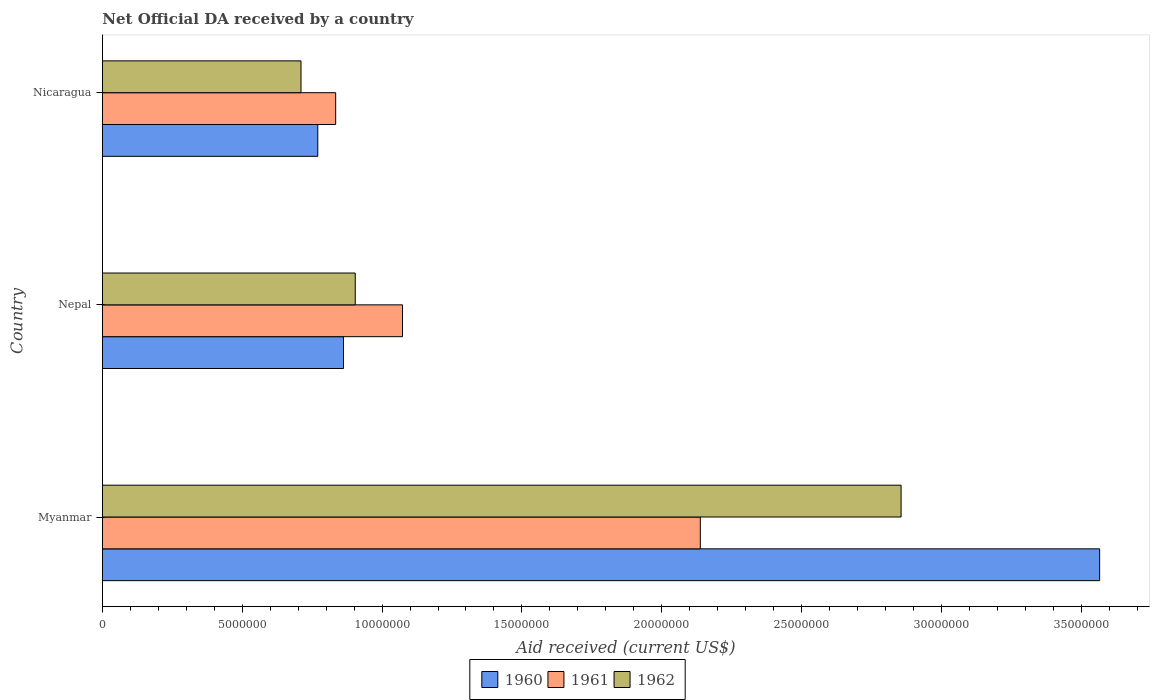Are the number of bars on each tick of the Y-axis equal?
Your answer should be compact. Yes. How many bars are there on the 3rd tick from the top?
Your answer should be compact. 3. How many bars are there on the 3rd tick from the bottom?
Make the answer very short. 3. What is the label of the 3rd group of bars from the top?
Provide a succinct answer. Myanmar. In how many cases, is the number of bars for a given country not equal to the number of legend labels?
Your answer should be very brief. 0. What is the net official development assistance aid received in 1960 in Nepal?
Your response must be concise. 8.62e+06. Across all countries, what is the maximum net official development assistance aid received in 1961?
Keep it short and to the point. 2.14e+07. Across all countries, what is the minimum net official development assistance aid received in 1960?
Make the answer very short. 7.70e+06. In which country was the net official development assistance aid received in 1960 maximum?
Make the answer very short. Myanmar. In which country was the net official development assistance aid received in 1960 minimum?
Keep it short and to the point. Nicaragua. What is the total net official development assistance aid received in 1960 in the graph?
Provide a short and direct response. 5.20e+07. What is the difference between the net official development assistance aid received in 1960 in Nepal and that in Nicaragua?
Keep it short and to the point. 9.20e+05. What is the difference between the net official development assistance aid received in 1960 in Nicaragua and the net official development assistance aid received in 1962 in Nepal?
Provide a succinct answer. -1.34e+06. What is the average net official development assistance aid received in 1962 per country?
Keep it short and to the point. 1.49e+07. What is the difference between the net official development assistance aid received in 1960 and net official development assistance aid received in 1962 in Myanmar?
Your response must be concise. 7.10e+06. What is the ratio of the net official development assistance aid received in 1960 in Myanmar to that in Nicaragua?
Offer a terse response. 4.63. Is the net official development assistance aid received in 1961 in Myanmar less than that in Nicaragua?
Ensure brevity in your answer.  No. Is the difference between the net official development assistance aid received in 1960 in Myanmar and Nepal greater than the difference between the net official development assistance aid received in 1962 in Myanmar and Nepal?
Offer a very short reply. Yes. What is the difference between the highest and the second highest net official development assistance aid received in 1960?
Offer a terse response. 2.70e+07. What is the difference between the highest and the lowest net official development assistance aid received in 1960?
Ensure brevity in your answer.  2.80e+07. In how many countries, is the net official development assistance aid received in 1960 greater than the average net official development assistance aid received in 1960 taken over all countries?
Your answer should be very brief. 1. What does the 3rd bar from the top in Myanmar represents?
Offer a terse response. 1960. What does the 2nd bar from the bottom in Nicaragua represents?
Offer a terse response. 1961. Is it the case that in every country, the sum of the net official development assistance aid received in 1961 and net official development assistance aid received in 1962 is greater than the net official development assistance aid received in 1960?
Keep it short and to the point. Yes. How many bars are there?
Offer a terse response. 9. What is the difference between two consecutive major ticks on the X-axis?
Offer a very short reply. 5.00e+06. Are the values on the major ticks of X-axis written in scientific E-notation?
Provide a short and direct response. No. Does the graph contain any zero values?
Your answer should be very brief. No. How are the legend labels stacked?
Offer a very short reply. Horizontal. What is the title of the graph?
Your answer should be compact. Net Official DA received by a country. What is the label or title of the X-axis?
Your answer should be very brief. Aid received (current US$). What is the label or title of the Y-axis?
Provide a short and direct response. Country. What is the Aid received (current US$) of 1960 in Myanmar?
Your response must be concise. 3.57e+07. What is the Aid received (current US$) of 1961 in Myanmar?
Your answer should be very brief. 2.14e+07. What is the Aid received (current US$) in 1962 in Myanmar?
Ensure brevity in your answer.  2.86e+07. What is the Aid received (current US$) of 1960 in Nepal?
Provide a short and direct response. 8.62e+06. What is the Aid received (current US$) of 1961 in Nepal?
Ensure brevity in your answer.  1.07e+07. What is the Aid received (current US$) of 1962 in Nepal?
Your answer should be compact. 9.04e+06. What is the Aid received (current US$) in 1960 in Nicaragua?
Ensure brevity in your answer.  7.70e+06. What is the Aid received (current US$) in 1961 in Nicaragua?
Keep it short and to the point. 8.34e+06. What is the Aid received (current US$) of 1962 in Nicaragua?
Your answer should be very brief. 7.10e+06. Across all countries, what is the maximum Aid received (current US$) of 1960?
Offer a very short reply. 3.57e+07. Across all countries, what is the maximum Aid received (current US$) in 1961?
Your response must be concise. 2.14e+07. Across all countries, what is the maximum Aid received (current US$) of 1962?
Make the answer very short. 2.86e+07. Across all countries, what is the minimum Aid received (current US$) of 1960?
Your response must be concise. 7.70e+06. Across all countries, what is the minimum Aid received (current US$) in 1961?
Provide a short and direct response. 8.34e+06. Across all countries, what is the minimum Aid received (current US$) in 1962?
Offer a very short reply. 7.10e+06. What is the total Aid received (current US$) of 1960 in the graph?
Your answer should be very brief. 5.20e+07. What is the total Aid received (current US$) in 1961 in the graph?
Offer a terse response. 4.04e+07. What is the total Aid received (current US$) in 1962 in the graph?
Ensure brevity in your answer.  4.47e+07. What is the difference between the Aid received (current US$) of 1960 in Myanmar and that in Nepal?
Your answer should be compact. 2.70e+07. What is the difference between the Aid received (current US$) in 1961 in Myanmar and that in Nepal?
Make the answer very short. 1.06e+07. What is the difference between the Aid received (current US$) of 1962 in Myanmar and that in Nepal?
Your answer should be compact. 1.95e+07. What is the difference between the Aid received (current US$) in 1960 in Myanmar and that in Nicaragua?
Offer a terse response. 2.80e+07. What is the difference between the Aid received (current US$) in 1961 in Myanmar and that in Nicaragua?
Your answer should be compact. 1.30e+07. What is the difference between the Aid received (current US$) of 1962 in Myanmar and that in Nicaragua?
Provide a succinct answer. 2.15e+07. What is the difference between the Aid received (current US$) in 1960 in Nepal and that in Nicaragua?
Your answer should be very brief. 9.20e+05. What is the difference between the Aid received (current US$) of 1961 in Nepal and that in Nicaragua?
Your response must be concise. 2.39e+06. What is the difference between the Aid received (current US$) in 1962 in Nepal and that in Nicaragua?
Make the answer very short. 1.94e+06. What is the difference between the Aid received (current US$) of 1960 in Myanmar and the Aid received (current US$) of 1961 in Nepal?
Ensure brevity in your answer.  2.49e+07. What is the difference between the Aid received (current US$) of 1960 in Myanmar and the Aid received (current US$) of 1962 in Nepal?
Give a very brief answer. 2.66e+07. What is the difference between the Aid received (current US$) of 1961 in Myanmar and the Aid received (current US$) of 1962 in Nepal?
Ensure brevity in your answer.  1.23e+07. What is the difference between the Aid received (current US$) in 1960 in Myanmar and the Aid received (current US$) in 1961 in Nicaragua?
Your answer should be very brief. 2.73e+07. What is the difference between the Aid received (current US$) in 1960 in Myanmar and the Aid received (current US$) in 1962 in Nicaragua?
Your answer should be compact. 2.86e+07. What is the difference between the Aid received (current US$) of 1961 in Myanmar and the Aid received (current US$) of 1962 in Nicaragua?
Ensure brevity in your answer.  1.43e+07. What is the difference between the Aid received (current US$) of 1960 in Nepal and the Aid received (current US$) of 1961 in Nicaragua?
Your answer should be very brief. 2.80e+05. What is the difference between the Aid received (current US$) in 1960 in Nepal and the Aid received (current US$) in 1962 in Nicaragua?
Provide a short and direct response. 1.52e+06. What is the difference between the Aid received (current US$) of 1961 in Nepal and the Aid received (current US$) of 1962 in Nicaragua?
Ensure brevity in your answer.  3.63e+06. What is the average Aid received (current US$) of 1960 per country?
Your response must be concise. 1.73e+07. What is the average Aid received (current US$) in 1961 per country?
Your response must be concise. 1.35e+07. What is the average Aid received (current US$) of 1962 per country?
Give a very brief answer. 1.49e+07. What is the difference between the Aid received (current US$) of 1960 and Aid received (current US$) of 1961 in Myanmar?
Offer a terse response. 1.43e+07. What is the difference between the Aid received (current US$) in 1960 and Aid received (current US$) in 1962 in Myanmar?
Your response must be concise. 7.10e+06. What is the difference between the Aid received (current US$) of 1961 and Aid received (current US$) of 1962 in Myanmar?
Offer a very short reply. -7.18e+06. What is the difference between the Aid received (current US$) of 1960 and Aid received (current US$) of 1961 in Nepal?
Give a very brief answer. -2.11e+06. What is the difference between the Aid received (current US$) of 1960 and Aid received (current US$) of 1962 in Nepal?
Keep it short and to the point. -4.20e+05. What is the difference between the Aid received (current US$) in 1961 and Aid received (current US$) in 1962 in Nepal?
Offer a very short reply. 1.69e+06. What is the difference between the Aid received (current US$) of 1960 and Aid received (current US$) of 1961 in Nicaragua?
Your response must be concise. -6.40e+05. What is the difference between the Aid received (current US$) in 1961 and Aid received (current US$) in 1962 in Nicaragua?
Offer a very short reply. 1.24e+06. What is the ratio of the Aid received (current US$) of 1960 in Myanmar to that in Nepal?
Give a very brief answer. 4.14. What is the ratio of the Aid received (current US$) in 1961 in Myanmar to that in Nepal?
Give a very brief answer. 1.99. What is the ratio of the Aid received (current US$) in 1962 in Myanmar to that in Nepal?
Your response must be concise. 3.16. What is the ratio of the Aid received (current US$) in 1960 in Myanmar to that in Nicaragua?
Provide a succinct answer. 4.63. What is the ratio of the Aid received (current US$) in 1961 in Myanmar to that in Nicaragua?
Offer a very short reply. 2.56. What is the ratio of the Aid received (current US$) of 1962 in Myanmar to that in Nicaragua?
Your response must be concise. 4.02. What is the ratio of the Aid received (current US$) of 1960 in Nepal to that in Nicaragua?
Offer a very short reply. 1.12. What is the ratio of the Aid received (current US$) in 1961 in Nepal to that in Nicaragua?
Your answer should be very brief. 1.29. What is the ratio of the Aid received (current US$) of 1962 in Nepal to that in Nicaragua?
Your answer should be very brief. 1.27. What is the difference between the highest and the second highest Aid received (current US$) of 1960?
Provide a succinct answer. 2.70e+07. What is the difference between the highest and the second highest Aid received (current US$) in 1961?
Your answer should be very brief. 1.06e+07. What is the difference between the highest and the second highest Aid received (current US$) in 1962?
Your answer should be very brief. 1.95e+07. What is the difference between the highest and the lowest Aid received (current US$) in 1960?
Give a very brief answer. 2.80e+07. What is the difference between the highest and the lowest Aid received (current US$) of 1961?
Give a very brief answer. 1.30e+07. What is the difference between the highest and the lowest Aid received (current US$) of 1962?
Offer a very short reply. 2.15e+07. 